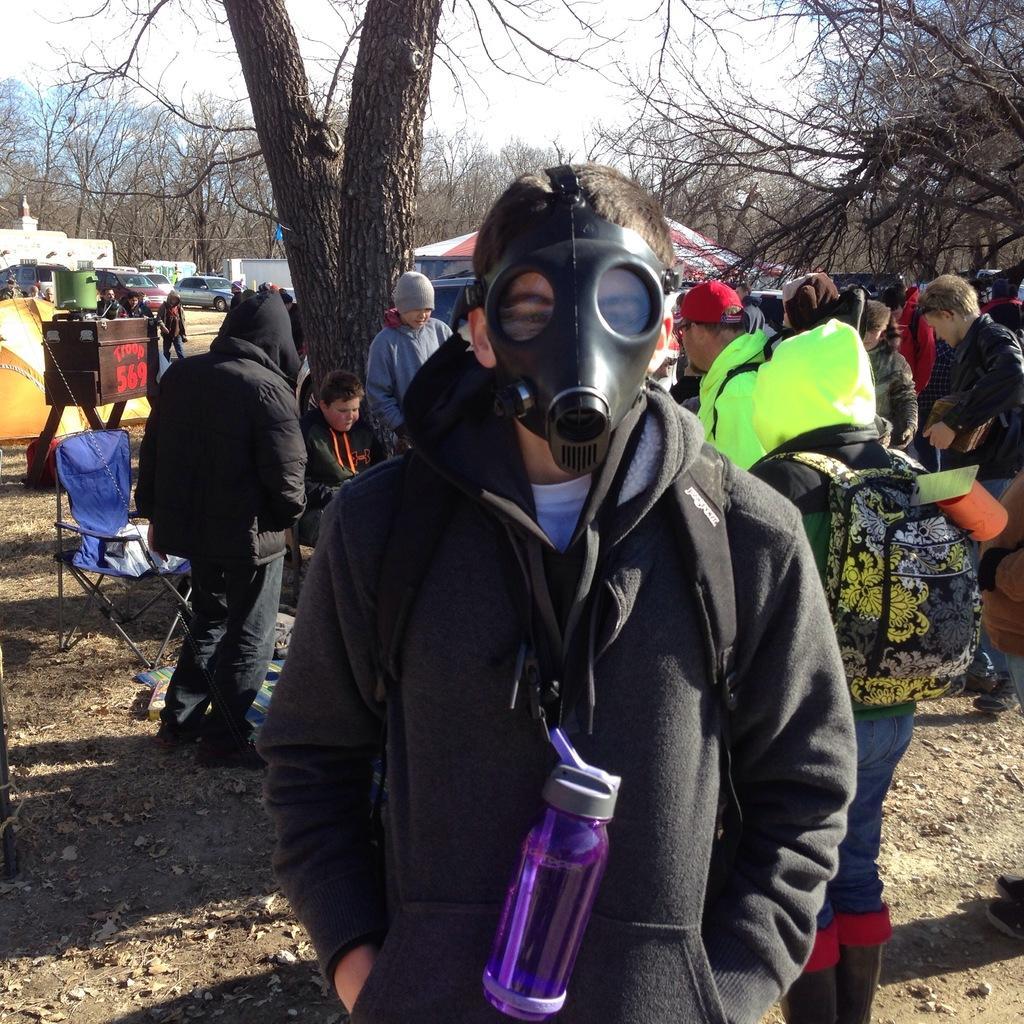How would you summarize this image in a sentence or two? In this image we can see some people and among them a person standing wearing a mask. In the background, we can see a few vehicles and some trees and there is a chair behind the person. 